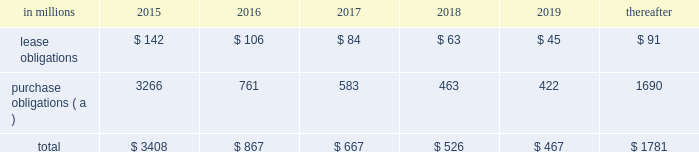At december 31 , 2014 , total future minimum commitments under existing non-cancelable operating leases and purchase obligations were as follows: .
( a ) includes $ 2.3 billion relating to fiber supply agreements entered into at the time of the company 2019s 2006 transformation plan forestland sales and in conjunction with the 2008 acquisition of weyerhaeuser company 2019s containerboard , packaging and recycling business .
Rent expense was $ 154 million , $ 168 million and $ 185 million for 2014 , 2013 and 2012 , respectively .
Guarantees in connection with sales of businesses , property , equipment , forestlands and other assets , international paper commonly makes representations and warranties relating to such businesses or assets , and may agree to indemnify buyers with respect to tax and environmental liabilities , breaches of representations and warranties , and other matters .
Where liabilities for such matters are determined to be probable and subject to reasonable estimation , accrued liabilities are recorded at the time of sale as a cost of the transaction .
Environmental proceedings cercla and state actions international paper has been named as a potentially responsible party in environmental remediation actions under various federal and state laws , including the comprehensive environmental response , compensation and liability act ( cercla ) .
Many of these proceedings involve the cleanup of hazardous substances at large commercial landfills that received waste from many different sources .
While joint and several liability is authorized under cercla and equivalent state laws , as a practical matter , liability for cercla cleanups is typically allocated among the many potential responsible parties .
Remedial costs are recorded in the consolidated financial statements when they become probable and reasonably estimable .
International paper has estimated the probable liability associated with these matters to be approximately $ 95 million in the aggregate as of december 31 , 2014 .
Cass lake : one of the matters referenced above is a closed wood treating facility located in cass lake , minnesota .
During 2009 , in connection with an environmental site remediation action under cercla , international paper submitted to the epa a remediation feasibility study .
In june 2011 , the epa selected and published a proposed soil remedy at the site with an estimated cost of $ 46 million .
The overall remediation reserve for the site is currently $ 50 million to address the selection of an alternative for the soil remediation component of the overall site remedy .
In october 2011 , the epa released a public statement indicating that the final soil remedy decision would be delayed .
In the unlikely event that the epa changes its proposed soil remedy and approves instead a more expensive clean- up alternative , the remediation costs could be material , and significantly higher than amounts currently recorded .
In october 2012 , the natural resource trustees for this site provided notice to international paper and other potentially responsible parties of their intent to perform a natural resource damage assessment .
It is premature to predict the outcome of the assessment or to estimate a loss or range of loss , if any , which may be incurred .
Other remediation costs in addition to the above matters , other remediation costs typically associated with the cleanup of hazardous substances at the company 2019s current , closed or formerly-owned facilities , and recorded as liabilities in the balance sheet , totaled approximately $ 41 million as of december 31 , 2014 .
Other than as described above , completion of required remedial actions is not expected to have a material effect on our consolidated financial statements .
Legal proceedings environmental kalamazoo river : the company is a potentially responsible party with respect to the allied paper , inc./ portage creek/kalamazoo river superfund site ( kalamazoo river superfund site ) in michigan .
The epa asserts that the site is contaminated primarily by pcbs as a result of discharges from various paper mills located along the kalamazoo river , including a paper mill formerly owned by st .
Regis paper company ( st .
Regis ) .
The company is a successor in interest to st .
Regis .
Although the company has not received any orders from the epa , in december 2014 , the epa sent the company a letter demanding payment of $ 19 million to reimburse the epa for costs associated with a time critical removal action of pcb contaminated sediments from a portion of the site .
The company 2019s cercla liability has not been finally determined with respect to this or any other portion of the site and we have declined to reimburse the epa at this time .
As noted below , the company is involved in allocation/ apportionment litigation with regard to the site .
Accordingly , it is premature to estimate a loss or range of loss with respect to this site .
The company was named as a defendant by georgia- pacific consumer products lp , fort james corporation and georgia pacific llc in a contribution and cost recovery action for alleged pollution at the site .
The suit .
In 2016 what percentage of december 31 , 2014 , total future minimum commitments under existing non-cancelable operating leases and purchase obligations is represented by lease obligations? 
Computations: (106 / 867)
Answer: 0.12226. 